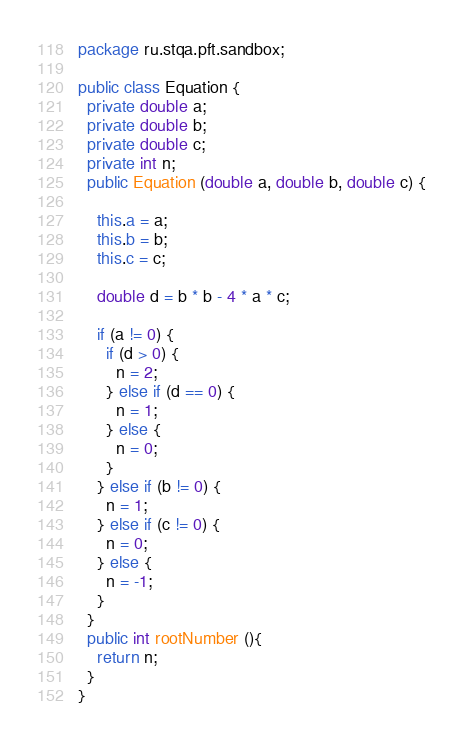Convert code to text. <code><loc_0><loc_0><loc_500><loc_500><_Java_>package ru.stqa.pft.sandbox;

public class Equation {
  private double a;
  private double b;
  private double c;
  private int n;
  public Equation (double a, double b, double c) {

    this.a = a;
    this.b = b;
    this.c = c;

    double d = b * b - 4 * a * c;

    if (a != 0) {
      if (d > 0) {
        n = 2;
      } else if (d == 0) {
        n = 1;
      } else {
        n = 0;
      }
    } else if (b != 0) {
      n = 1;
    } else if (c != 0) {
      n = 0;
    } else {
      n = -1;
    }
  }
  public int rootNumber (){
    return n;
  }
}

</code> 